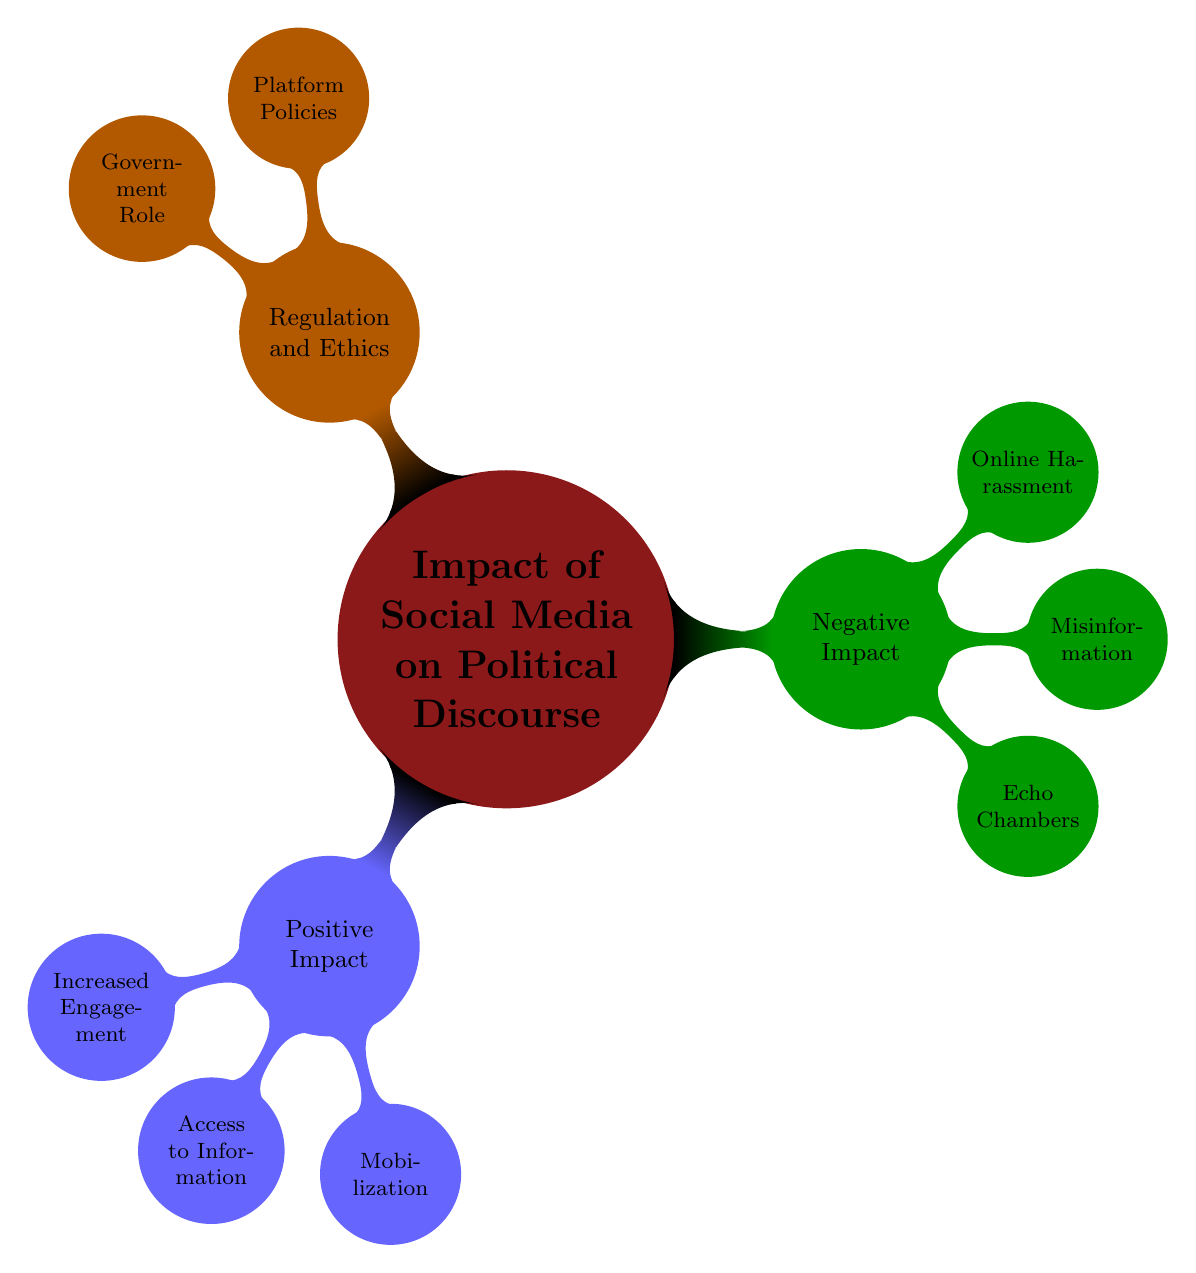What is one positive impact of social media on political discourse? The diagram indicates that one positive impact is increased engagement, which is a direct sub-node under positive impact.
Answer: Increased engagement How many categories are there under the negative impact of social media? The diagram shows three specific nodes under the negative impact category: echo chambers, misinformation, and online harassment, indicating a count of three.
Answer: Three What aspects fall under access to information? The access to information node has two sub-nodes: sources and citizen journalism. This indicates that access to information incorporates various aspects regarding where information comes from and how it is generated by citizens.
Answer: Sources and citizen journalism Which social movements are examples of mobilization? The mobilization node lists three movements: #BlackLivesMatter, #MeToo, and Climate Strikes, showcasing the types of significant social movements that have gained traction through social media.
Answer: #BlackLivesMatter, #MeToo, Climate Strikes What are two types of misinformation mentioned in the diagram? The misinformation node presents three types, two of which are listed as fake news and deep fakes, demonstrating common forms of misinformation distributed.
Answer: Fake news, deep fakes What is the function of platform policies mentioned under regulation and ethics? The platform policies node details aspects such as content moderation and user agreements, indicating their role in managing how content is presented and interacting with users on social media platforms.
Answer: Managing content and user interactions What is one form of online harassment targeted at political figures? The online harassment node states that one form is trolling, which is a method of harassment directed at individuals, including political figures.
Answer: Trolling What role do government initiatives play in relation to regulation and ethics? Under the government role category, initiatives such as fact-checking agencies and digital literacy programs are included, indicating that governments take steps to ensure informed citizenry and accountability.
Answer: Ensuring informed citizenry and accountability 